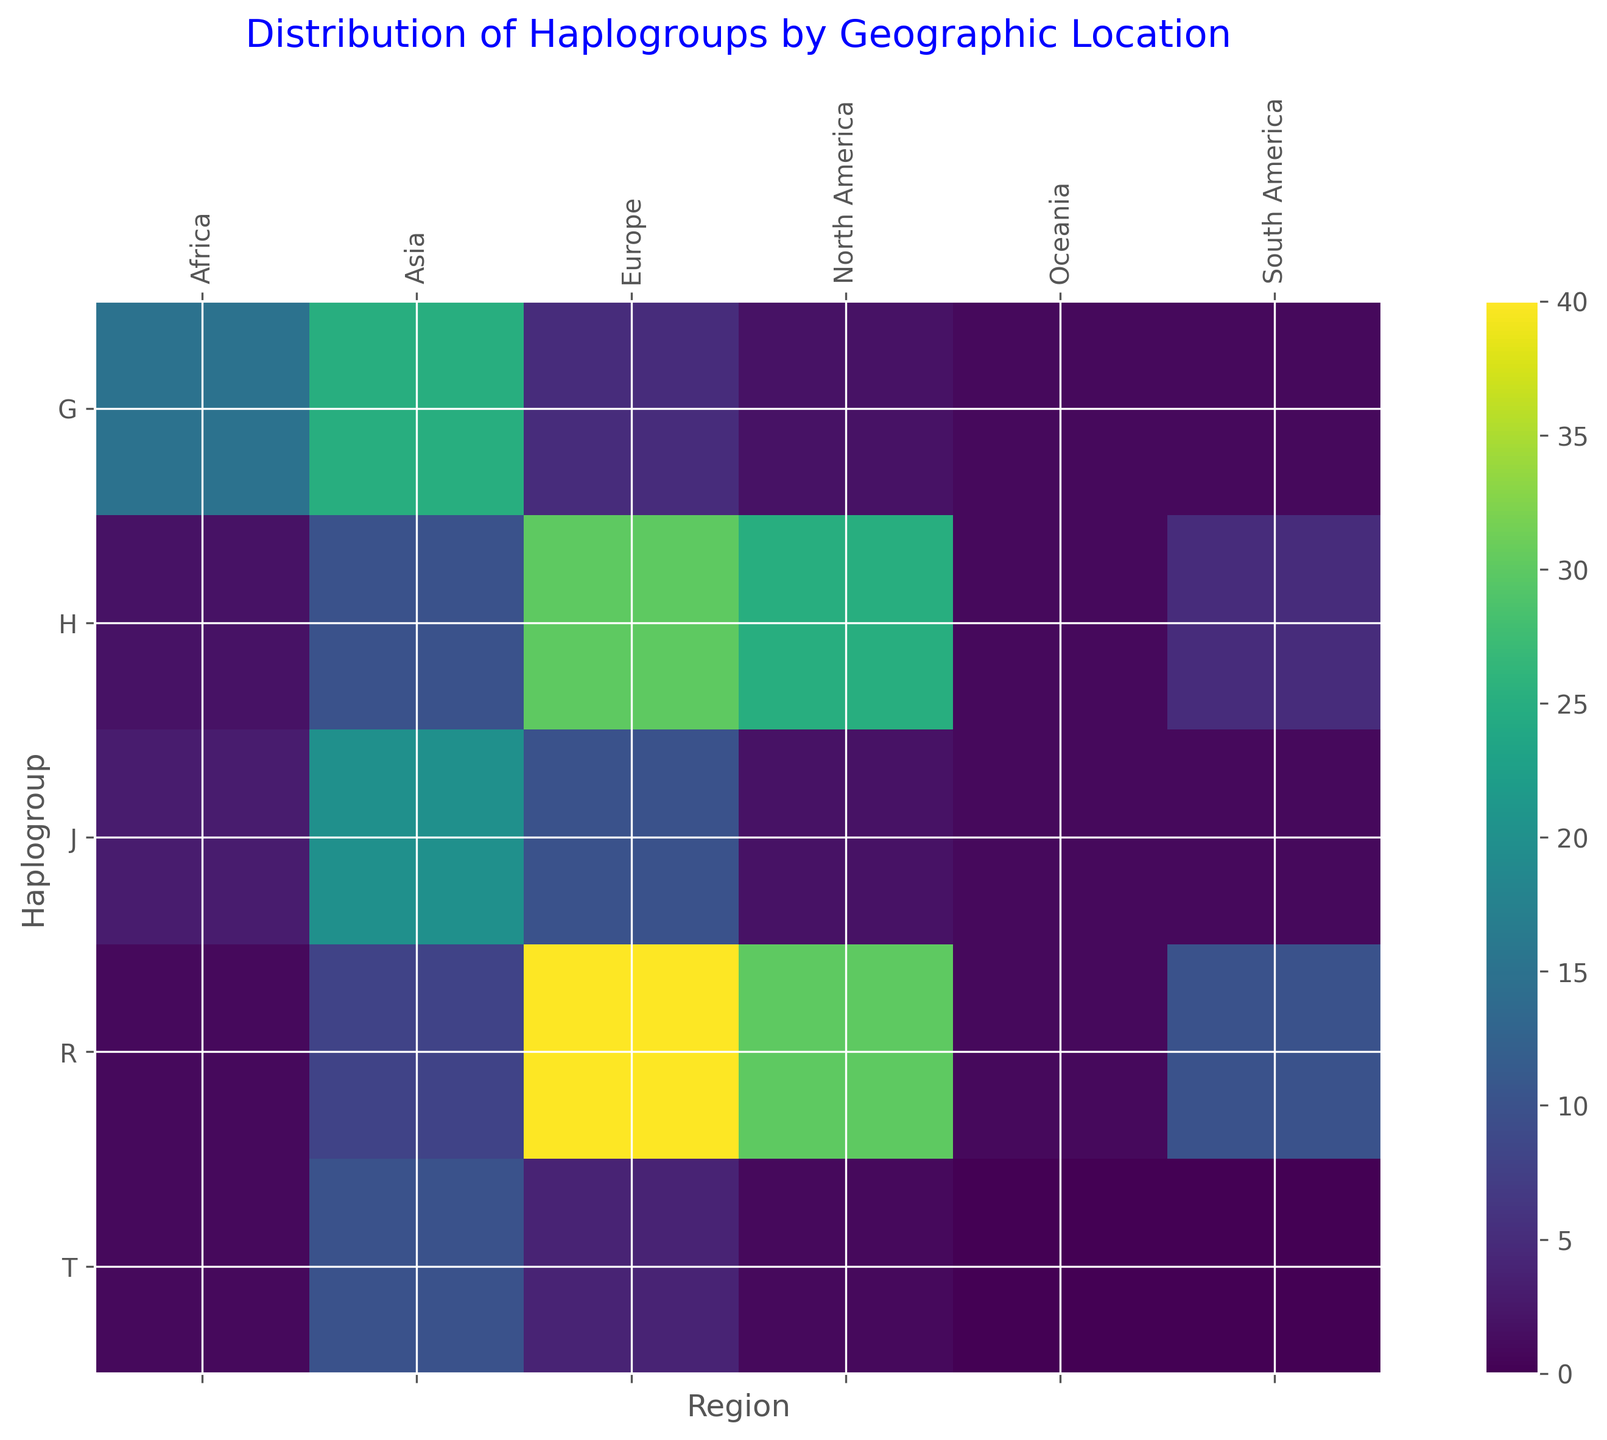What's the most common haplogroup in Asia? First, identify the regions labeled on the x-axis, find "Asia", and then see which row has the cell with the highest brightness (i.e., most intense color) in the Asia column. This corresponds to a frequency of 25, under haplogroup G.
Answer: G Which region has the highest frequency of haplogroup H? Locate the row for haplogroup H on the y-axis. Then move horizontally along this row to compare the different regions. The highest value of 30 occurs under the "Europe" column.
Answer: Europe How does the distribution of haplogroup T in Europe compare to its distribution in Asia? Find haplogroup T on the y-axis and compare the color intensities in the corresponding cells under "Europe" and "Asia". The intensity is higher in Asia (darker shade) than in Europe. The exact values are 10 for Asia and 4 for Europe.
Answer: T is more common in Asia than in Europe Calculate the total frequency of haplogroup R across all regions. Add the values from the row corresponding to haplogroup R: 40 (Europe) + 30 (North America) + 10 (South America) + 1 (Africa) + 8 (Asia) + 1 (Oceania) = 90.
Answer: 90 Which haplogroup is least frequent in Africa? Navigate to the column for Africa on the x-axis and compare the values in each row. The lowest values are for haplogroups H, R, and T, which all have a value of 1.
Answer: H, R, T Between haplogroups J and G, which one has a higher total frequency in North America? Sum the values for haplogroups J and G in the North America column: J has 2, and G has 2. Both have the same frequency.
Answer: Same What is the difference in frequency of haplogroup R between Europe and Asia? Identify the values for R in Europe and Asia, which are 40 and 8, respectively. The difference is 40 - 8 = 32.
Answer: 32 Among haplogroups H, J, and T, which one has the lowest total frequency across all regions? Sum the frequencies across all regions for H, J, and T: H = 30+25+5+2+10+1 = 73, J=10+2+1+3+20+1=37, T=4+1+0+1+10+0=16. Haplogroup T has the lowest total frequency.
Answer: T What is the average frequency of haplogroup G across Europe, North America, and Asia? Calculate the average frequency for haplogroup G across the three mentioned regions: (5+2+25)/3 = 32/3 ≈ 10.67.
Answer: 10.67 